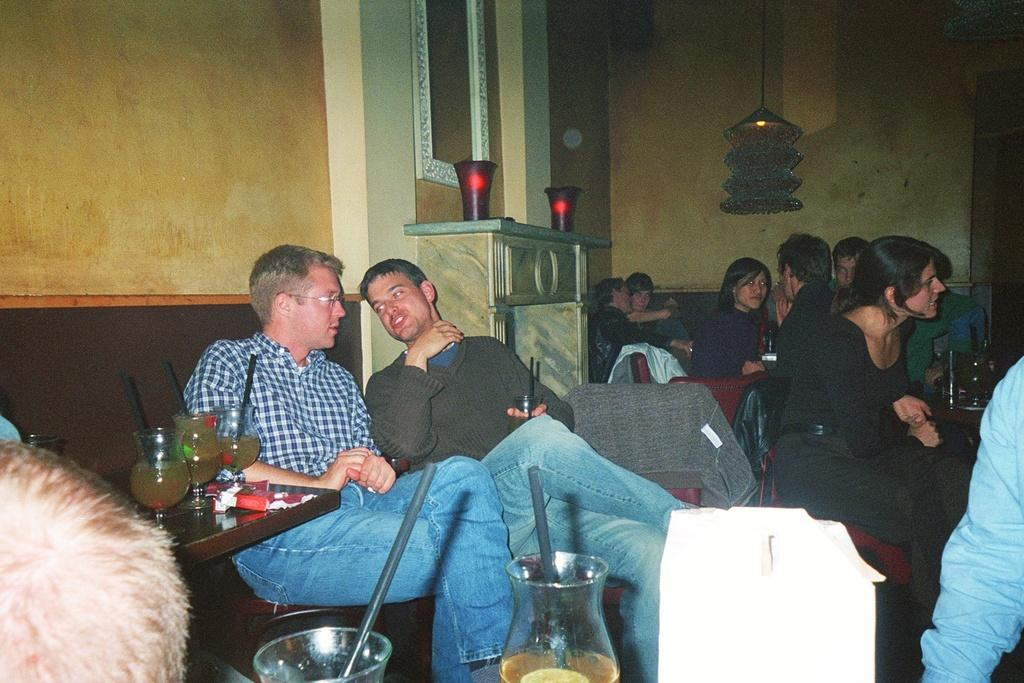What are the people in the image doing? The people in the image are sitting around tables. What can be found on the tables? The tables contain glasses. What type of lighting is present in the image? There are lamps in the image. What type of fuel is being used by the lizards in the image? There are no lizards present in the image, so the question cannot be answered. 